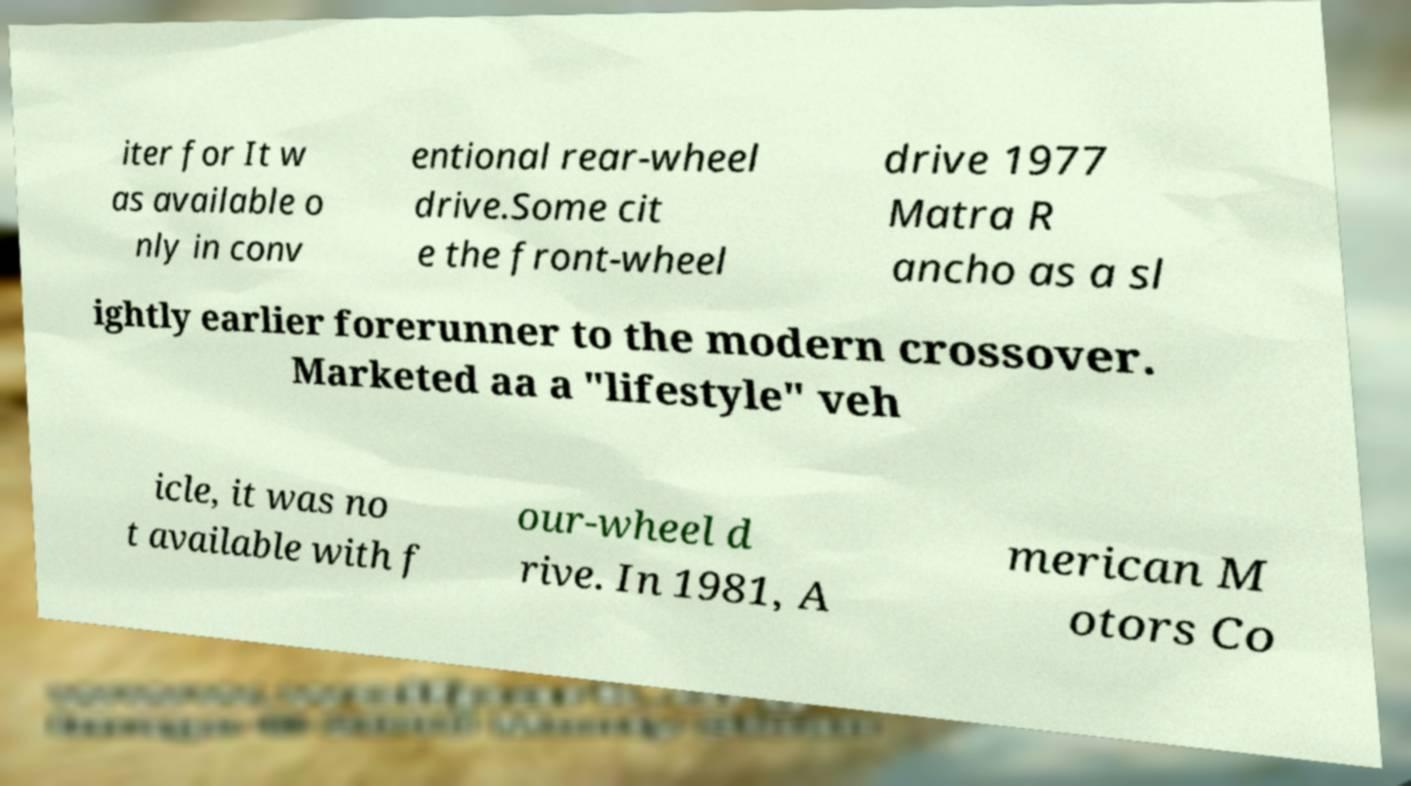What messages or text are displayed in this image? I need them in a readable, typed format. iter for It w as available o nly in conv entional rear-wheel drive.Some cit e the front-wheel drive 1977 Matra R ancho as a sl ightly earlier forerunner to the modern crossover. Marketed aa a "lifestyle" veh icle, it was no t available with f our-wheel d rive. In 1981, A merican M otors Co 